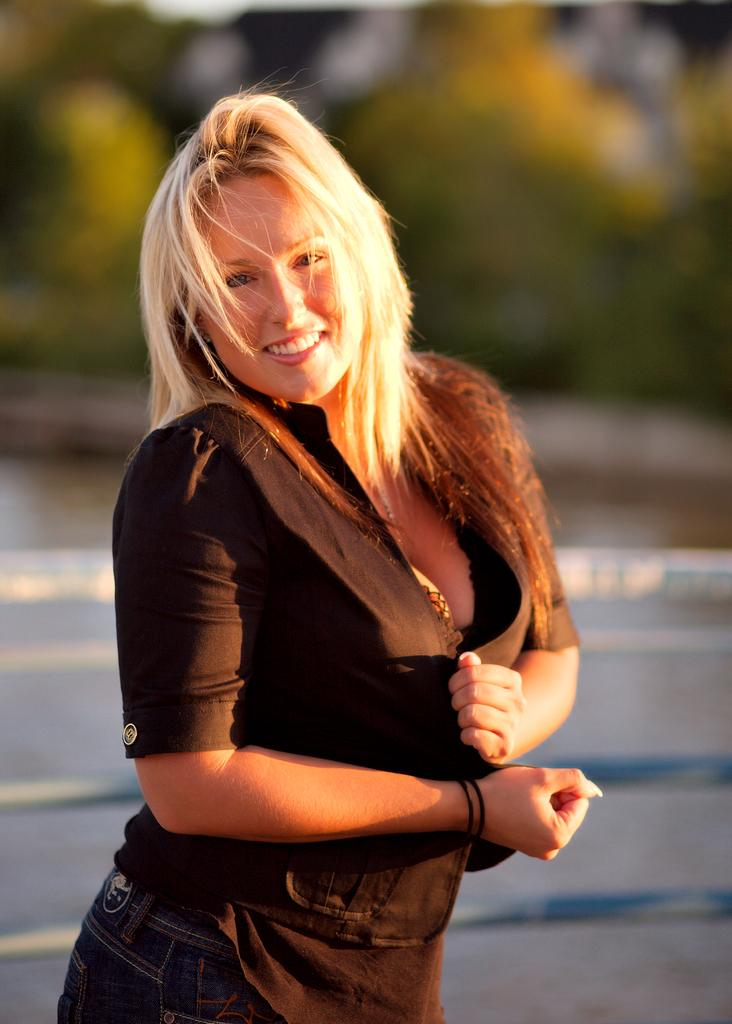Who is present in the image? There is a woman in the image. What is the woman wearing? The woman is wearing a black dress. What is the woman doing in the image? The woman is standing and smiling. What can be seen in the background of the image? There are trees, the ground, and the sky visible in the background of the image. What type of corn can be seen growing on the roof in the image? There is no corn or roof present in the image; it features a woman standing and smiling with trees, the ground, and the sky visible in the background. 